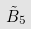Convert formula to latex. <formula><loc_0><loc_0><loc_500><loc_500>\tilde { B } _ { 5 }</formula> 